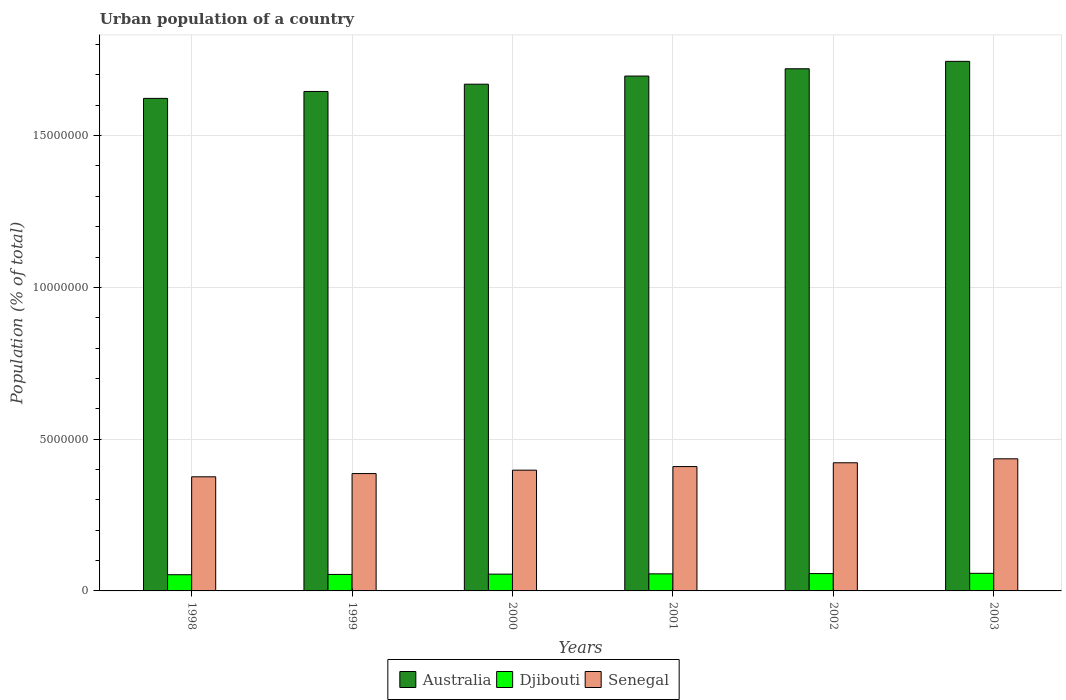How many different coloured bars are there?
Ensure brevity in your answer.  3. Are the number of bars per tick equal to the number of legend labels?
Make the answer very short. Yes. Are the number of bars on each tick of the X-axis equal?
Offer a terse response. Yes. How many bars are there on the 4th tick from the left?
Provide a short and direct response. 3. How many bars are there on the 4th tick from the right?
Your answer should be very brief. 3. What is the urban population in Senegal in 2003?
Keep it short and to the point. 4.35e+06. Across all years, what is the maximum urban population in Senegal?
Your response must be concise. 4.35e+06. Across all years, what is the minimum urban population in Djibouti?
Your answer should be very brief. 5.34e+05. In which year was the urban population in Australia maximum?
Offer a very short reply. 2003. In which year was the urban population in Australia minimum?
Make the answer very short. 1998. What is the total urban population in Australia in the graph?
Your response must be concise. 1.01e+08. What is the difference between the urban population in Senegal in 2000 and that in 2001?
Make the answer very short. -1.19e+05. What is the difference between the urban population in Senegal in 1998 and the urban population in Australia in 2001?
Offer a terse response. -1.32e+07. What is the average urban population in Australia per year?
Provide a succinct answer. 1.68e+07. In the year 1998, what is the difference between the urban population in Djibouti and urban population in Australia?
Keep it short and to the point. -1.57e+07. In how many years, is the urban population in Senegal greater than 11000000 %?
Give a very brief answer. 0. What is the ratio of the urban population in Senegal in 2000 to that in 2001?
Provide a short and direct response. 0.97. Is the urban population in Senegal in 1998 less than that in 2002?
Your answer should be very brief. Yes. Is the difference between the urban population in Djibouti in 1998 and 2002 greater than the difference between the urban population in Australia in 1998 and 2002?
Offer a very short reply. Yes. What is the difference between the highest and the second highest urban population in Australia?
Keep it short and to the point. 2.44e+05. What is the difference between the highest and the lowest urban population in Djibouti?
Ensure brevity in your answer.  4.64e+04. What does the 3rd bar from the left in 2000 represents?
Offer a terse response. Senegal. What does the 2nd bar from the right in 2001 represents?
Keep it short and to the point. Djibouti. How many bars are there?
Make the answer very short. 18. Are all the bars in the graph horizontal?
Provide a succinct answer. No. Does the graph contain any zero values?
Offer a very short reply. No. Where does the legend appear in the graph?
Your answer should be compact. Bottom center. How are the legend labels stacked?
Offer a very short reply. Horizontal. What is the title of the graph?
Make the answer very short. Urban population of a country. What is the label or title of the X-axis?
Your answer should be very brief. Years. What is the label or title of the Y-axis?
Ensure brevity in your answer.  Population (% of total). What is the Population (% of total) in Australia in 1998?
Make the answer very short. 1.62e+07. What is the Population (% of total) in Djibouti in 1998?
Ensure brevity in your answer.  5.34e+05. What is the Population (% of total) in Senegal in 1998?
Your answer should be very brief. 3.76e+06. What is the Population (% of total) of Australia in 1999?
Offer a very short reply. 1.65e+07. What is the Population (% of total) in Djibouti in 1999?
Your response must be concise. 5.44e+05. What is the Population (% of total) in Senegal in 1999?
Provide a short and direct response. 3.87e+06. What is the Population (% of total) of Australia in 2000?
Offer a terse response. 1.67e+07. What is the Population (% of total) in Djibouti in 2000?
Make the answer very short. 5.53e+05. What is the Population (% of total) of Senegal in 2000?
Provide a short and direct response. 3.98e+06. What is the Population (% of total) in Australia in 2001?
Offer a very short reply. 1.70e+07. What is the Population (% of total) in Djibouti in 2001?
Provide a succinct answer. 5.62e+05. What is the Population (% of total) in Senegal in 2001?
Provide a succinct answer. 4.10e+06. What is the Population (% of total) in Australia in 2002?
Your answer should be very brief. 1.72e+07. What is the Population (% of total) in Djibouti in 2002?
Make the answer very short. 5.71e+05. What is the Population (% of total) in Senegal in 2002?
Offer a very short reply. 4.22e+06. What is the Population (% of total) in Australia in 2003?
Give a very brief answer. 1.74e+07. What is the Population (% of total) of Djibouti in 2003?
Provide a short and direct response. 5.80e+05. What is the Population (% of total) of Senegal in 2003?
Provide a short and direct response. 4.35e+06. Across all years, what is the maximum Population (% of total) of Australia?
Give a very brief answer. 1.74e+07. Across all years, what is the maximum Population (% of total) of Djibouti?
Offer a very short reply. 5.80e+05. Across all years, what is the maximum Population (% of total) of Senegal?
Your answer should be compact. 4.35e+06. Across all years, what is the minimum Population (% of total) in Australia?
Your response must be concise. 1.62e+07. Across all years, what is the minimum Population (% of total) of Djibouti?
Keep it short and to the point. 5.34e+05. Across all years, what is the minimum Population (% of total) in Senegal?
Offer a terse response. 3.76e+06. What is the total Population (% of total) in Australia in the graph?
Your response must be concise. 1.01e+08. What is the total Population (% of total) of Djibouti in the graph?
Offer a very short reply. 3.34e+06. What is the total Population (% of total) in Senegal in the graph?
Offer a very short reply. 2.43e+07. What is the difference between the Population (% of total) of Australia in 1998 and that in 1999?
Offer a terse response. -2.28e+05. What is the difference between the Population (% of total) in Djibouti in 1998 and that in 1999?
Offer a very short reply. -9802. What is the difference between the Population (% of total) in Senegal in 1998 and that in 1999?
Provide a short and direct response. -1.06e+05. What is the difference between the Population (% of total) of Australia in 1998 and that in 2000?
Ensure brevity in your answer.  -4.67e+05. What is the difference between the Population (% of total) in Djibouti in 1998 and that in 2000?
Ensure brevity in your answer.  -1.93e+04. What is the difference between the Population (% of total) in Senegal in 1998 and that in 2000?
Offer a terse response. -2.18e+05. What is the difference between the Population (% of total) of Australia in 1998 and that in 2001?
Offer a very short reply. -7.35e+05. What is the difference between the Population (% of total) in Djibouti in 1998 and that in 2001?
Your answer should be very brief. -2.84e+04. What is the difference between the Population (% of total) of Senegal in 1998 and that in 2001?
Provide a succinct answer. -3.37e+05. What is the difference between the Population (% of total) of Australia in 1998 and that in 2002?
Ensure brevity in your answer.  -9.76e+05. What is the difference between the Population (% of total) in Djibouti in 1998 and that in 2002?
Provide a succinct answer. -3.75e+04. What is the difference between the Population (% of total) in Senegal in 1998 and that in 2002?
Ensure brevity in your answer.  -4.62e+05. What is the difference between the Population (% of total) in Australia in 1998 and that in 2003?
Keep it short and to the point. -1.22e+06. What is the difference between the Population (% of total) of Djibouti in 1998 and that in 2003?
Provide a succinct answer. -4.64e+04. What is the difference between the Population (% of total) in Senegal in 1998 and that in 2003?
Offer a terse response. -5.93e+05. What is the difference between the Population (% of total) in Australia in 1999 and that in 2000?
Provide a short and direct response. -2.39e+05. What is the difference between the Population (% of total) of Djibouti in 1999 and that in 2000?
Provide a short and direct response. -9449. What is the difference between the Population (% of total) of Senegal in 1999 and that in 2000?
Provide a succinct answer. -1.12e+05. What is the difference between the Population (% of total) in Australia in 1999 and that in 2001?
Offer a terse response. -5.07e+05. What is the difference between the Population (% of total) of Djibouti in 1999 and that in 2001?
Offer a terse response. -1.86e+04. What is the difference between the Population (% of total) of Senegal in 1999 and that in 2001?
Give a very brief answer. -2.31e+05. What is the difference between the Population (% of total) of Australia in 1999 and that in 2002?
Make the answer very short. -7.47e+05. What is the difference between the Population (% of total) of Djibouti in 1999 and that in 2002?
Your response must be concise. -2.77e+04. What is the difference between the Population (% of total) of Senegal in 1999 and that in 2002?
Offer a terse response. -3.56e+05. What is the difference between the Population (% of total) in Australia in 1999 and that in 2003?
Ensure brevity in your answer.  -9.92e+05. What is the difference between the Population (% of total) of Djibouti in 1999 and that in 2003?
Your response must be concise. -3.66e+04. What is the difference between the Population (% of total) in Senegal in 1999 and that in 2003?
Your answer should be compact. -4.87e+05. What is the difference between the Population (% of total) in Australia in 2000 and that in 2001?
Your response must be concise. -2.68e+05. What is the difference between the Population (% of total) in Djibouti in 2000 and that in 2001?
Offer a terse response. -9159. What is the difference between the Population (% of total) in Senegal in 2000 and that in 2001?
Keep it short and to the point. -1.19e+05. What is the difference between the Population (% of total) of Australia in 2000 and that in 2002?
Keep it short and to the point. -5.08e+05. What is the difference between the Population (% of total) in Djibouti in 2000 and that in 2002?
Your answer should be compact. -1.82e+04. What is the difference between the Population (% of total) in Senegal in 2000 and that in 2002?
Ensure brevity in your answer.  -2.44e+05. What is the difference between the Population (% of total) in Australia in 2000 and that in 2003?
Ensure brevity in your answer.  -7.53e+05. What is the difference between the Population (% of total) of Djibouti in 2000 and that in 2003?
Make the answer very short. -2.71e+04. What is the difference between the Population (% of total) of Senegal in 2000 and that in 2003?
Offer a terse response. -3.75e+05. What is the difference between the Population (% of total) of Australia in 2001 and that in 2002?
Keep it short and to the point. -2.40e+05. What is the difference between the Population (% of total) in Djibouti in 2001 and that in 2002?
Make the answer very short. -9051. What is the difference between the Population (% of total) in Senegal in 2001 and that in 2002?
Give a very brief answer. -1.25e+05. What is the difference between the Population (% of total) in Australia in 2001 and that in 2003?
Offer a terse response. -4.85e+05. What is the difference between the Population (% of total) in Djibouti in 2001 and that in 2003?
Ensure brevity in your answer.  -1.80e+04. What is the difference between the Population (% of total) of Senegal in 2001 and that in 2003?
Your answer should be compact. -2.56e+05. What is the difference between the Population (% of total) in Australia in 2002 and that in 2003?
Your answer should be compact. -2.44e+05. What is the difference between the Population (% of total) in Djibouti in 2002 and that in 2003?
Provide a succinct answer. -8927. What is the difference between the Population (% of total) of Senegal in 2002 and that in 2003?
Your answer should be compact. -1.31e+05. What is the difference between the Population (% of total) of Australia in 1998 and the Population (% of total) of Djibouti in 1999?
Your answer should be compact. 1.57e+07. What is the difference between the Population (% of total) in Australia in 1998 and the Population (% of total) in Senegal in 1999?
Ensure brevity in your answer.  1.24e+07. What is the difference between the Population (% of total) in Djibouti in 1998 and the Population (% of total) in Senegal in 1999?
Offer a terse response. -3.33e+06. What is the difference between the Population (% of total) in Australia in 1998 and the Population (% of total) in Djibouti in 2000?
Your answer should be compact. 1.57e+07. What is the difference between the Population (% of total) of Australia in 1998 and the Population (% of total) of Senegal in 2000?
Your answer should be compact. 1.22e+07. What is the difference between the Population (% of total) in Djibouti in 1998 and the Population (% of total) in Senegal in 2000?
Offer a terse response. -3.44e+06. What is the difference between the Population (% of total) in Australia in 1998 and the Population (% of total) in Djibouti in 2001?
Your response must be concise. 1.57e+07. What is the difference between the Population (% of total) in Australia in 1998 and the Population (% of total) in Senegal in 2001?
Offer a terse response. 1.21e+07. What is the difference between the Population (% of total) of Djibouti in 1998 and the Population (% of total) of Senegal in 2001?
Your response must be concise. -3.56e+06. What is the difference between the Population (% of total) in Australia in 1998 and the Population (% of total) in Djibouti in 2002?
Ensure brevity in your answer.  1.57e+07. What is the difference between the Population (% of total) in Australia in 1998 and the Population (% of total) in Senegal in 2002?
Your answer should be very brief. 1.20e+07. What is the difference between the Population (% of total) in Djibouti in 1998 and the Population (% of total) in Senegal in 2002?
Your response must be concise. -3.69e+06. What is the difference between the Population (% of total) of Australia in 1998 and the Population (% of total) of Djibouti in 2003?
Make the answer very short. 1.56e+07. What is the difference between the Population (% of total) of Australia in 1998 and the Population (% of total) of Senegal in 2003?
Keep it short and to the point. 1.19e+07. What is the difference between the Population (% of total) in Djibouti in 1998 and the Population (% of total) in Senegal in 2003?
Make the answer very short. -3.82e+06. What is the difference between the Population (% of total) in Australia in 1999 and the Population (% of total) in Djibouti in 2000?
Give a very brief answer. 1.59e+07. What is the difference between the Population (% of total) in Australia in 1999 and the Population (% of total) in Senegal in 2000?
Give a very brief answer. 1.25e+07. What is the difference between the Population (% of total) of Djibouti in 1999 and the Population (% of total) of Senegal in 2000?
Give a very brief answer. -3.43e+06. What is the difference between the Population (% of total) of Australia in 1999 and the Population (% of total) of Djibouti in 2001?
Provide a succinct answer. 1.59e+07. What is the difference between the Population (% of total) of Australia in 1999 and the Population (% of total) of Senegal in 2001?
Offer a very short reply. 1.24e+07. What is the difference between the Population (% of total) in Djibouti in 1999 and the Population (% of total) in Senegal in 2001?
Your answer should be compact. -3.55e+06. What is the difference between the Population (% of total) of Australia in 1999 and the Population (% of total) of Djibouti in 2002?
Provide a succinct answer. 1.59e+07. What is the difference between the Population (% of total) in Australia in 1999 and the Population (% of total) in Senegal in 2002?
Offer a terse response. 1.22e+07. What is the difference between the Population (% of total) of Djibouti in 1999 and the Population (% of total) of Senegal in 2002?
Provide a succinct answer. -3.68e+06. What is the difference between the Population (% of total) of Australia in 1999 and the Population (% of total) of Djibouti in 2003?
Your answer should be compact. 1.59e+07. What is the difference between the Population (% of total) in Australia in 1999 and the Population (% of total) in Senegal in 2003?
Make the answer very short. 1.21e+07. What is the difference between the Population (% of total) in Djibouti in 1999 and the Population (% of total) in Senegal in 2003?
Make the answer very short. -3.81e+06. What is the difference between the Population (% of total) of Australia in 2000 and the Population (% of total) of Djibouti in 2001?
Offer a terse response. 1.61e+07. What is the difference between the Population (% of total) of Australia in 2000 and the Population (% of total) of Senegal in 2001?
Provide a short and direct response. 1.26e+07. What is the difference between the Population (% of total) of Djibouti in 2000 and the Population (% of total) of Senegal in 2001?
Your answer should be compact. -3.54e+06. What is the difference between the Population (% of total) in Australia in 2000 and the Population (% of total) in Djibouti in 2002?
Make the answer very short. 1.61e+07. What is the difference between the Population (% of total) of Australia in 2000 and the Population (% of total) of Senegal in 2002?
Offer a very short reply. 1.25e+07. What is the difference between the Population (% of total) of Djibouti in 2000 and the Population (% of total) of Senegal in 2002?
Ensure brevity in your answer.  -3.67e+06. What is the difference between the Population (% of total) of Australia in 2000 and the Population (% of total) of Djibouti in 2003?
Make the answer very short. 1.61e+07. What is the difference between the Population (% of total) in Australia in 2000 and the Population (% of total) in Senegal in 2003?
Provide a succinct answer. 1.23e+07. What is the difference between the Population (% of total) in Djibouti in 2000 and the Population (% of total) in Senegal in 2003?
Your answer should be very brief. -3.80e+06. What is the difference between the Population (% of total) in Australia in 2001 and the Population (% of total) in Djibouti in 2002?
Give a very brief answer. 1.64e+07. What is the difference between the Population (% of total) in Australia in 2001 and the Population (% of total) in Senegal in 2002?
Your answer should be very brief. 1.27e+07. What is the difference between the Population (% of total) in Djibouti in 2001 and the Population (% of total) in Senegal in 2002?
Offer a terse response. -3.66e+06. What is the difference between the Population (% of total) in Australia in 2001 and the Population (% of total) in Djibouti in 2003?
Offer a terse response. 1.64e+07. What is the difference between the Population (% of total) of Australia in 2001 and the Population (% of total) of Senegal in 2003?
Offer a terse response. 1.26e+07. What is the difference between the Population (% of total) in Djibouti in 2001 and the Population (% of total) in Senegal in 2003?
Keep it short and to the point. -3.79e+06. What is the difference between the Population (% of total) of Australia in 2002 and the Population (% of total) of Djibouti in 2003?
Keep it short and to the point. 1.66e+07. What is the difference between the Population (% of total) in Australia in 2002 and the Population (% of total) in Senegal in 2003?
Your response must be concise. 1.29e+07. What is the difference between the Population (% of total) in Djibouti in 2002 and the Population (% of total) in Senegal in 2003?
Ensure brevity in your answer.  -3.78e+06. What is the average Population (% of total) of Australia per year?
Offer a terse response. 1.68e+07. What is the average Population (% of total) of Djibouti per year?
Offer a terse response. 5.57e+05. What is the average Population (% of total) of Senegal per year?
Give a very brief answer. 4.05e+06. In the year 1998, what is the difference between the Population (% of total) of Australia and Population (% of total) of Djibouti?
Your answer should be very brief. 1.57e+07. In the year 1998, what is the difference between the Population (% of total) of Australia and Population (% of total) of Senegal?
Provide a short and direct response. 1.25e+07. In the year 1998, what is the difference between the Population (% of total) of Djibouti and Population (% of total) of Senegal?
Ensure brevity in your answer.  -3.23e+06. In the year 1999, what is the difference between the Population (% of total) in Australia and Population (% of total) in Djibouti?
Your answer should be very brief. 1.59e+07. In the year 1999, what is the difference between the Population (% of total) in Australia and Population (% of total) in Senegal?
Your answer should be compact. 1.26e+07. In the year 1999, what is the difference between the Population (% of total) of Djibouti and Population (% of total) of Senegal?
Provide a succinct answer. -3.32e+06. In the year 2000, what is the difference between the Population (% of total) in Australia and Population (% of total) in Djibouti?
Make the answer very short. 1.61e+07. In the year 2000, what is the difference between the Population (% of total) of Australia and Population (% of total) of Senegal?
Provide a short and direct response. 1.27e+07. In the year 2000, what is the difference between the Population (% of total) in Djibouti and Population (% of total) in Senegal?
Keep it short and to the point. -3.43e+06. In the year 2001, what is the difference between the Population (% of total) of Australia and Population (% of total) of Djibouti?
Offer a terse response. 1.64e+07. In the year 2001, what is the difference between the Population (% of total) in Australia and Population (% of total) in Senegal?
Make the answer very short. 1.29e+07. In the year 2001, what is the difference between the Population (% of total) of Djibouti and Population (% of total) of Senegal?
Offer a terse response. -3.53e+06. In the year 2002, what is the difference between the Population (% of total) of Australia and Population (% of total) of Djibouti?
Provide a succinct answer. 1.66e+07. In the year 2002, what is the difference between the Population (% of total) in Australia and Population (% of total) in Senegal?
Your answer should be very brief. 1.30e+07. In the year 2002, what is the difference between the Population (% of total) of Djibouti and Population (% of total) of Senegal?
Keep it short and to the point. -3.65e+06. In the year 2003, what is the difference between the Population (% of total) of Australia and Population (% of total) of Djibouti?
Your response must be concise. 1.69e+07. In the year 2003, what is the difference between the Population (% of total) of Australia and Population (% of total) of Senegal?
Offer a very short reply. 1.31e+07. In the year 2003, what is the difference between the Population (% of total) in Djibouti and Population (% of total) in Senegal?
Make the answer very short. -3.77e+06. What is the ratio of the Population (% of total) of Australia in 1998 to that in 1999?
Provide a short and direct response. 0.99. What is the ratio of the Population (% of total) in Djibouti in 1998 to that in 1999?
Your answer should be compact. 0.98. What is the ratio of the Population (% of total) in Senegal in 1998 to that in 1999?
Ensure brevity in your answer.  0.97. What is the ratio of the Population (% of total) in Australia in 1998 to that in 2000?
Offer a terse response. 0.97. What is the ratio of the Population (% of total) of Djibouti in 1998 to that in 2000?
Offer a terse response. 0.97. What is the ratio of the Population (% of total) in Senegal in 1998 to that in 2000?
Give a very brief answer. 0.95. What is the ratio of the Population (% of total) of Australia in 1998 to that in 2001?
Offer a terse response. 0.96. What is the ratio of the Population (% of total) of Djibouti in 1998 to that in 2001?
Give a very brief answer. 0.95. What is the ratio of the Population (% of total) in Senegal in 1998 to that in 2001?
Keep it short and to the point. 0.92. What is the ratio of the Population (% of total) of Australia in 1998 to that in 2002?
Offer a very short reply. 0.94. What is the ratio of the Population (% of total) in Djibouti in 1998 to that in 2002?
Offer a terse response. 0.93. What is the ratio of the Population (% of total) of Senegal in 1998 to that in 2002?
Offer a terse response. 0.89. What is the ratio of the Population (% of total) in Australia in 1998 to that in 2003?
Your answer should be compact. 0.93. What is the ratio of the Population (% of total) of Djibouti in 1998 to that in 2003?
Make the answer very short. 0.92. What is the ratio of the Population (% of total) of Senegal in 1998 to that in 2003?
Provide a succinct answer. 0.86. What is the ratio of the Population (% of total) of Australia in 1999 to that in 2000?
Your answer should be compact. 0.99. What is the ratio of the Population (% of total) of Djibouti in 1999 to that in 2000?
Your response must be concise. 0.98. What is the ratio of the Population (% of total) of Senegal in 1999 to that in 2000?
Your answer should be very brief. 0.97. What is the ratio of the Population (% of total) in Australia in 1999 to that in 2001?
Keep it short and to the point. 0.97. What is the ratio of the Population (% of total) in Djibouti in 1999 to that in 2001?
Provide a succinct answer. 0.97. What is the ratio of the Population (% of total) in Senegal in 1999 to that in 2001?
Make the answer very short. 0.94. What is the ratio of the Population (% of total) of Australia in 1999 to that in 2002?
Keep it short and to the point. 0.96. What is the ratio of the Population (% of total) of Djibouti in 1999 to that in 2002?
Your response must be concise. 0.95. What is the ratio of the Population (% of total) of Senegal in 1999 to that in 2002?
Provide a short and direct response. 0.92. What is the ratio of the Population (% of total) of Australia in 1999 to that in 2003?
Your answer should be very brief. 0.94. What is the ratio of the Population (% of total) in Djibouti in 1999 to that in 2003?
Ensure brevity in your answer.  0.94. What is the ratio of the Population (% of total) in Senegal in 1999 to that in 2003?
Keep it short and to the point. 0.89. What is the ratio of the Population (% of total) in Australia in 2000 to that in 2001?
Give a very brief answer. 0.98. What is the ratio of the Population (% of total) of Djibouti in 2000 to that in 2001?
Provide a short and direct response. 0.98. What is the ratio of the Population (% of total) of Senegal in 2000 to that in 2001?
Offer a very short reply. 0.97. What is the ratio of the Population (% of total) in Australia in 2000 to that in 2002?
Offer a terse response. 0.97. What is the ratio of the Population (% of total) in Djibouti in 2000 to that in 2002?
Offer a terse response. 0.97. What is the ratio of the Population (% of total) in Senegal in 2000 to that in 2002?
Keep it short and to the point. 0.94. What is the ratio of the Population (% of total) in Australia in 2000 to that in 2003?
Ensure brevity in your answer.  0.96. What is the ratio of the Population (% of total) in Djibouti in 2000 to that in 2003?
Your answer should be very brief. 0.95. What is the ratio of the Population (% of total) in Senegal in 2000 to that in 2003?
Make the answer very short. 0.91. What is the ratio of the Population (% of total) of Australia in 2001 to that in 2002?
Your response must be concise. 0.99. What is the ratio of the Population (% of total) in Djibouti in 2001 to that in 2002?
Offer a very short reply. 0.98. What is the ratio of the Population (% of total) in Senegal in 2001 to that in 2002?
Provide a short and direct response. 0.97. What is the ratio of the Population (% of total) of Australia in 2001 to that in 2003?
Provide a short and direct response. 0.97. What is the ratio of the Population (% of total) of Senegal in 2001 to that in 2003?
Keep it short and to the point. 0.94. What is the ratio of the Population (% of total) of Australia in 2002 to that in 2003?
Your answer should be very brief. 0.99. What is the ratio of the Population (% of total) of Djibouti in 2002 to that in 2003?
Your response must be concise. 0.98. What is the ratio of the Population (% of total) in Senegal in 2002 to that in 2003?
Your response must be concise. 0.97. What is the difference between the highest and the second highest Population (% of total) of Australia?
Give a very brief answer. 2.44e+05. What is the difference between the highest and the second highest Population (% of total) in Djibouti?
Your answer should be compact. 8927. What is the difference between the highest and the second highest Population (% of total) of Senegal?
Your answer should be very brief. 1.31e+05. What is the difference between the highest and the lowest Population (% of total) in Australia?
Give a very brief answer. 1.22e+06. What is the difference between the highest and the lowest Population (% of total) in Djibouti?
Your response must be concise. 4.64e+04. What is the difference between the highest and the lowest Population (% of total) of Senegal?
Ensure brevity in your answer.  5.93e+05. 